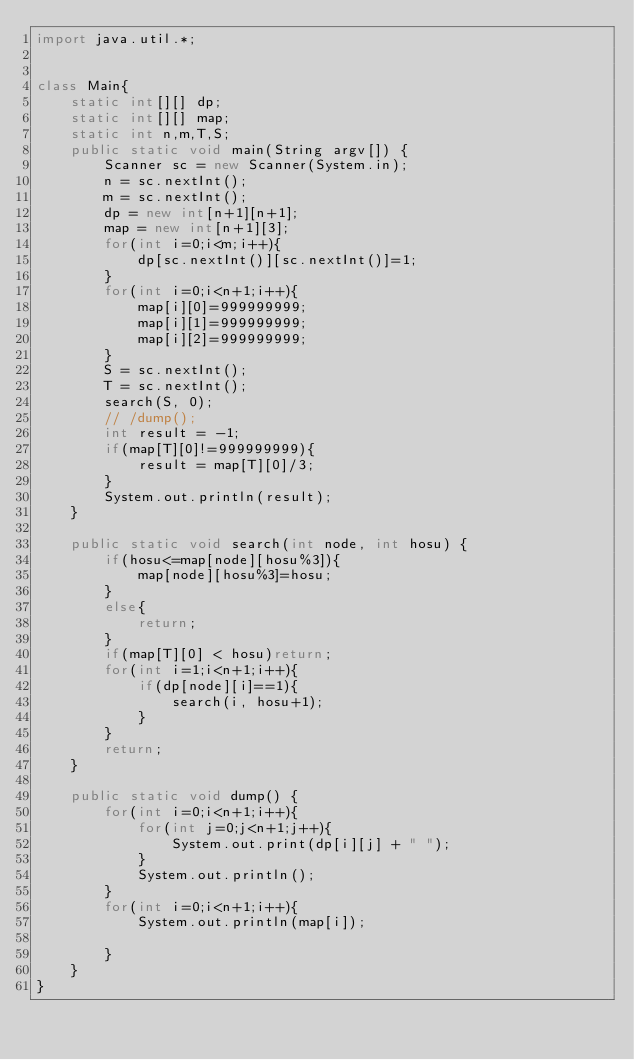<code> <loc_0><loc_0><loc_500><loc_500><_Java_>import java.util.*;


class Main{
    static int[][] dp;
    static int[][] map;
    static int n,m,T,S;
    public static void main(String argv[]) {
        Scanner sc = new Scanner(System.in);
        n = sc.nextInt();
        m = sc.nextInt();
        dp = new int[n+1][n+1];
        map = new int[n+1][3];
        for(int i=0;i<m;i++){
            dp[sc.nextInt()][sc.nextInt()]=1;
        }
        for(int i=0;i<n+1;i++){
            map[i][0]=999999999;
            map[i][1]=999999999;
            map[i][2]=999999999;
        }
        S = sc.nextInt();
        T = sc.nextInt();
        search(S, 0);
        // /dump();
        int result = -1;
        if(map[T][0]!=999999999){
            result = map[T][0]/3;
        }
        System.out.println(result);
    }

    public static void search(int node, int hosu) {
        if(hosu<=map[node][hosu%3]){
            map[node][hosu%3]=hosu;
        }
        else{
            return;
        }
        if(map[T][0] < hosu)return;
        for(int i=1;i<n+1;i++){
            if(dp[node][i]==1){
                search(i, hosu+1);
            }
        }
        return;
    }

    public static void dump() {
        for(int i=0;i<n+1;i++){
            for(int j=0;j<n+1;j++){
                System.out.print(dp[i][j] + " ");
            }
            System.out.println();
        }
        for(int i=0;i<n+1;i++){
            System.out.println(map[i]);

        }
    }
}</code> 